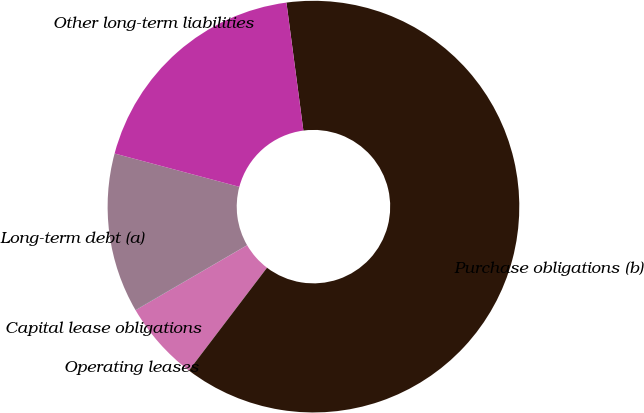Convert chart. <chart><loc_0><loc_0><loc_500><loc_500><pie_chart><fcel>Long-term debt (a)<fcel>Capital lease obligations<fcel>Operating leases<fcel>Purchase obligations (b)<fcel>Other long-term liabilities<nl><fcel>12.51%<fcel>0.03%<fcel>6.27%<fcel>62.44%<fcel>18.75%<nl></chart> 